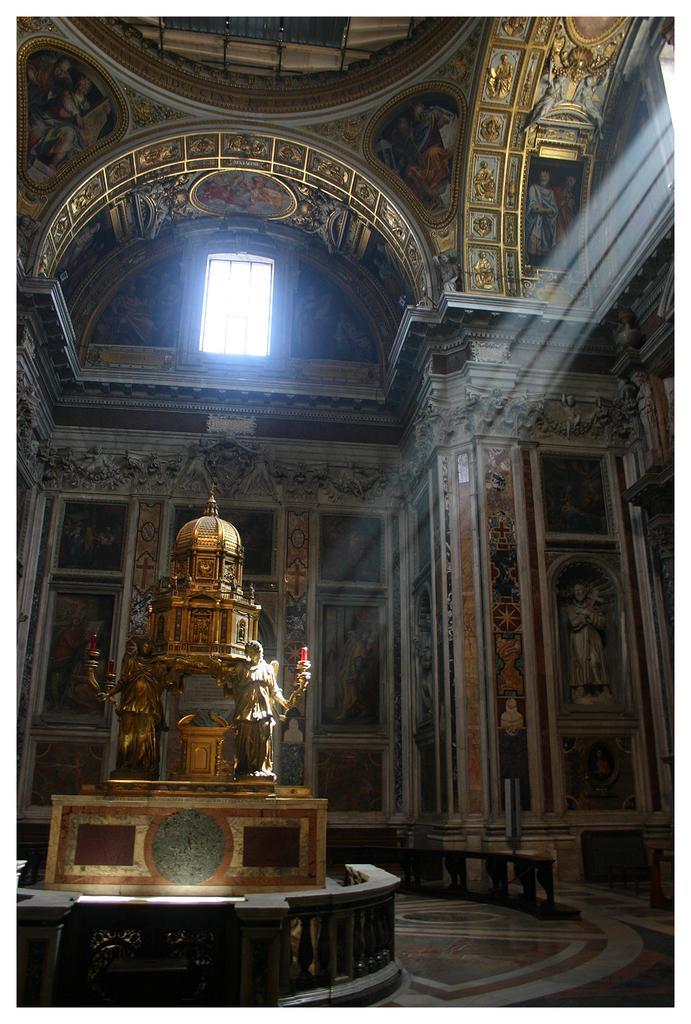How would you summarize this image in a sentence or two? In this picture I can see there is a monument and there is a statue placed on the rock. There are windows on to top right and center of the wall. 